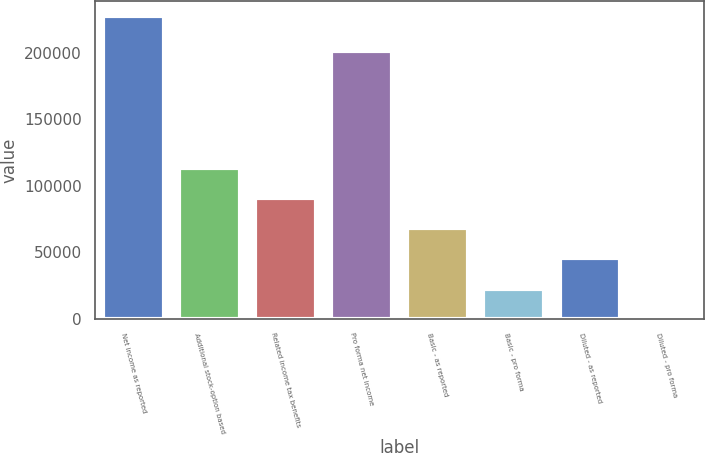Convert chart to OTSL. <chart><loc_0><loc_0><loc_500><loc_500><bar_chart><fcel>Net income as reported<fcel>Additional stock-option based<fcel>Related income tax benefits<fcel>Pro forma net income<fcel>Basic - as reported<fcel>Basic - pro forma<fcel>Diluted - as reported<fcel>Diluted - pro forma<nl><fcel>227487<fcel>113744<fcel>90995.8<fcel>201707<fcel>68247.2<fcel>22750.1<fcel>45498.7<fcel>1.59<nl></chart> 